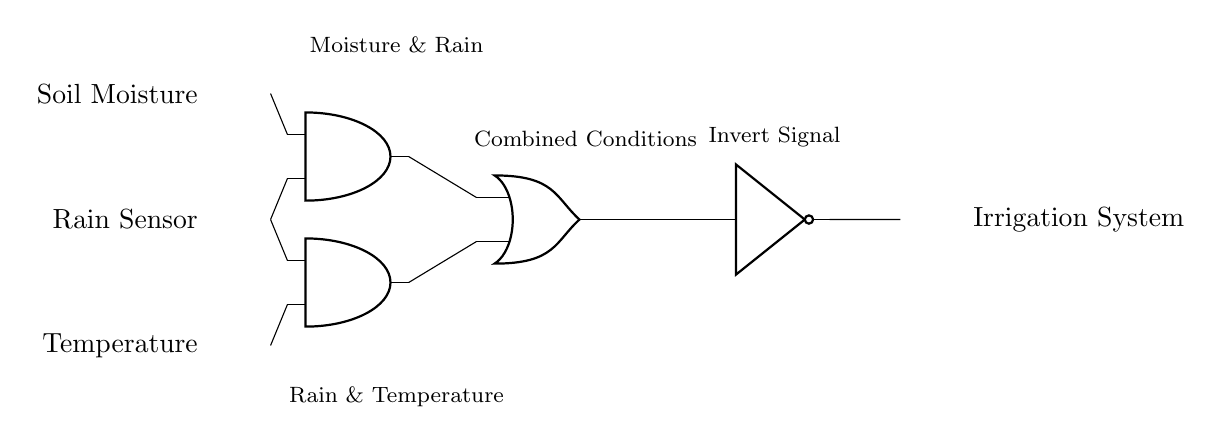What are the input sensors in this circuit? The input sensors are listed on the left side of the circuit diagram, indicating that there are three types: Soil Moisture, Rain Sensor, and Temperature.
Answer: Soil Moisture, Rain Sensor, Temperature How many AND gates are present in the circuit? By examining the circuit diagram, two AND gates can be identified, positioned at (2,3) and (2,1).
Answer: 2 What variables are combined by the first AND gate? The first AND gate takes inputs from the Soil Moisture sensor and the Rain Sensor, as indicated by the lines connecting them to the input terminals of the AND gate.
Answer: Soil Moisture and Rain Sensor What is the output of the OR gate dependent on? The output of the OR gate depends on the outputs from the two AND gates; it outputs a signal if either condition from the AND gates is true, which means it considers both sets of inputs for irrigation.
Answer: Outputs from the two AND gates What happens to the signal after it passes through the NOT gate? The NOT gate inverts the signal coming from the OR gate, meaning it changes a true signal to false and vice versa, effectively acting as a switch before reaching the Irrigation System output.
Answer: Signal inversion 